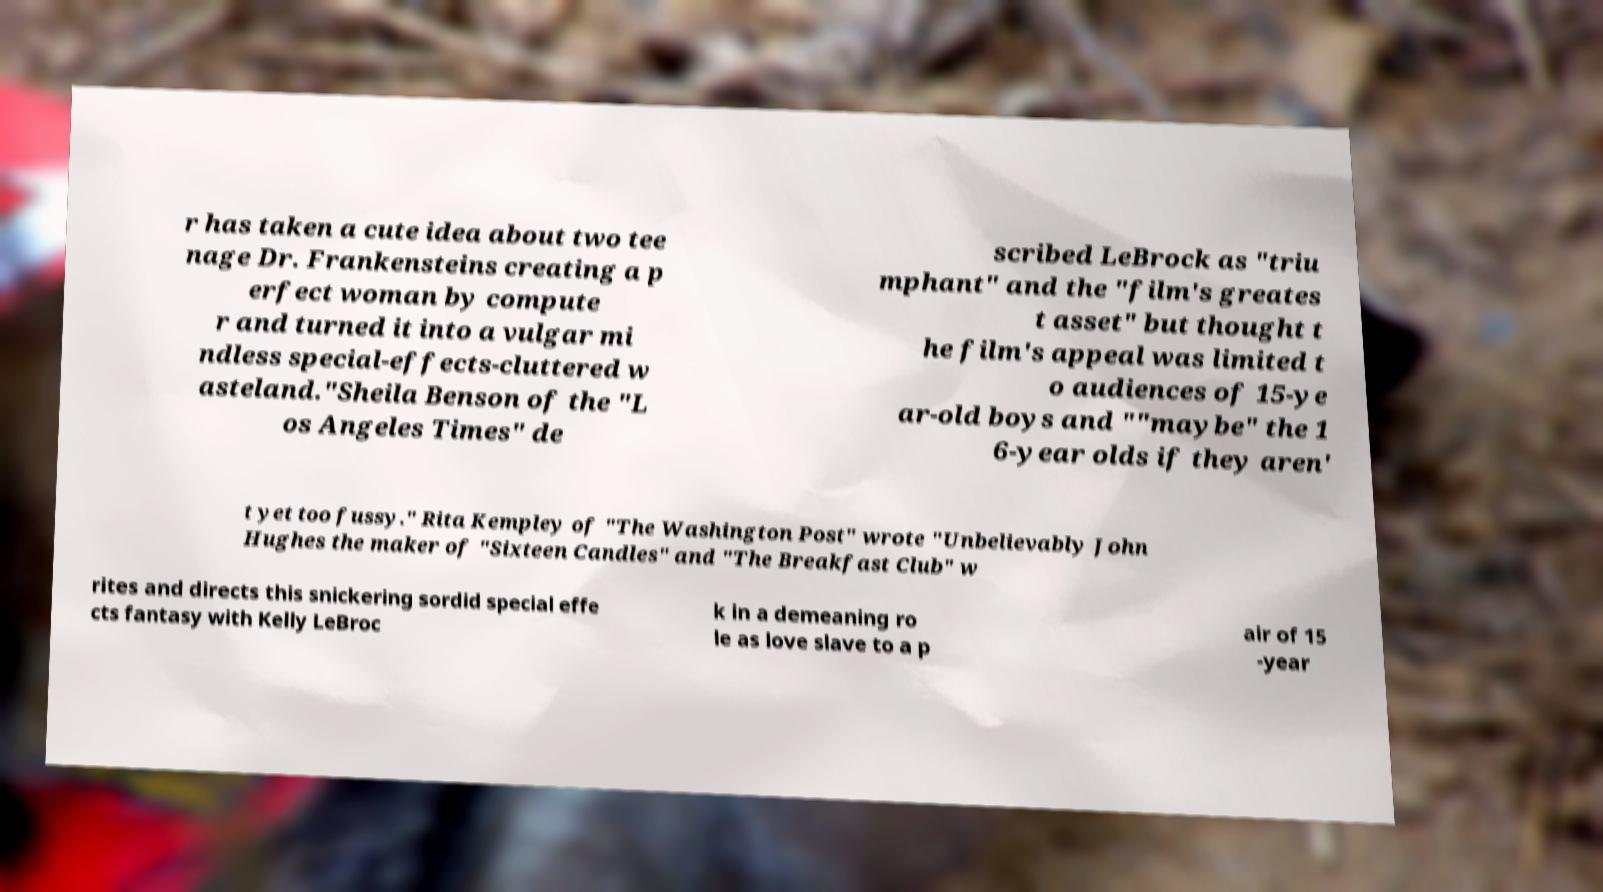What messages or text are displayed in this image? I need them in a readable, typed format. r has taken a cute idea about two tee nage Dr. Frankensteins creating a p erfect woman by compute r and turned it into a vulgar mi ndless special-effects-cluttered w asteland."Sheila Benson of the "L os Angeles Times" de scribed LeBrock as "triu mphant" and the "film's greates t asset" but thought t he film's appeal was limited t o audiences of 15-ye ar-old boys and ""maybe" the 1 6-year olds if they aren' t yet too fussy." Rita Kempley of "The Washington Post" wrote "Unbelievably John Hughes the maker of "Sixteen Candles" and "The Breakfast Club" w rites and directs this snickering sordid special effe cts fantasy with Kelly LeBroc k in a demeaning ro le as love slave to a p air of 15 -year 